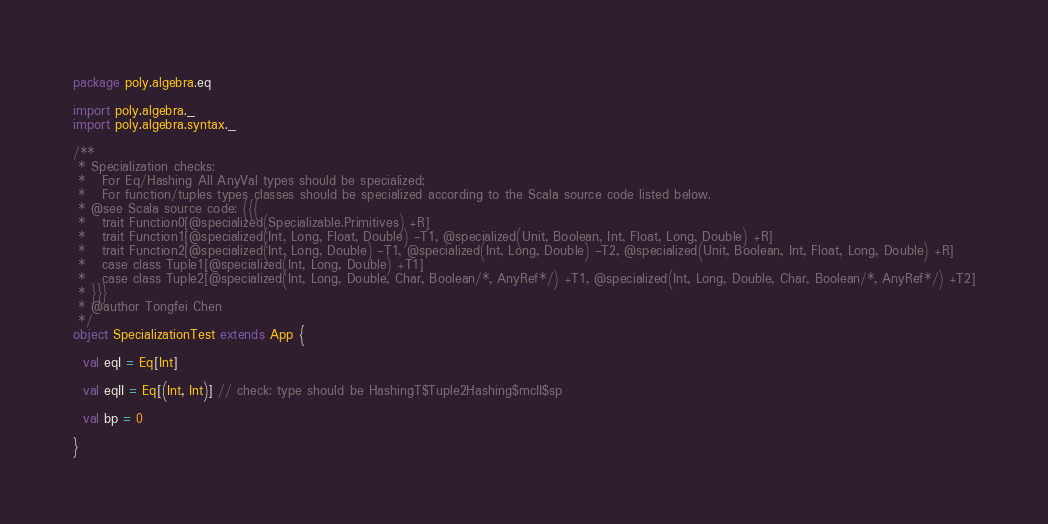<code> <loc_0><loc_0><loc_500><loc_500><_Scala_>package poly.algebra.eq

import poly.algebra._
import poly.algebra.syntax._

/**
 * Specialization checks:
 *   For Eq/Hashing All AnyVal types should be specialized;
 *   For function/tuples types classes should be specialized according to the Scala source code listed below.
 * @see Scala source code: {{{
 *   trait Function0[@specialized(Specializable.Primitives) +R]
 *   trait Function1[@specialized(Int, Long, Float, Double) -T1, @specialized(Unit, Boolean, Int, Float, Long, Double) +R]
 *   trait Function2[@specialized(Int, Long, Double) -T1, @specialized(Int, Long, Double) -T2, @specialized(Unit, Boolean, Int, Float, Long, Double) +R]
 *   case class Tuple1[@specialized(Int, Long, Double) +T1]
 *   case class Tuple2[@specialized(Int, Long, Double, Char, Boolean/*, AnyRef*/) +T1, @specialized(Int, Long, Double, Char, Boolean/*, AnyRef*/) +T2]
 * }}}
 * @author Tongfei Chen
 */
object SpecializationTest extends App {

  val eqI = Eq[Int]

  val eqII = Eq[(Int, Int)] // check: type should be HashingT$Tuple2Hashing$mcII$sp

  val bp = 0

}
</code> 